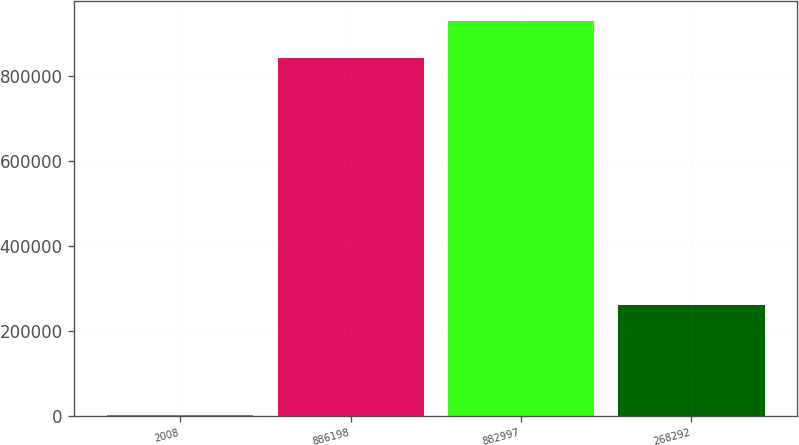Convert chart to OTSL. <chart><loc_0><loc_0><loc_500><loc_500><bar_chart><fcel>2008<fcel>886198<fcel>882997<fcel>268292<nl><fcel>2008<fcel>841629<fcel>929827<fcel>260291<nl></chart> 